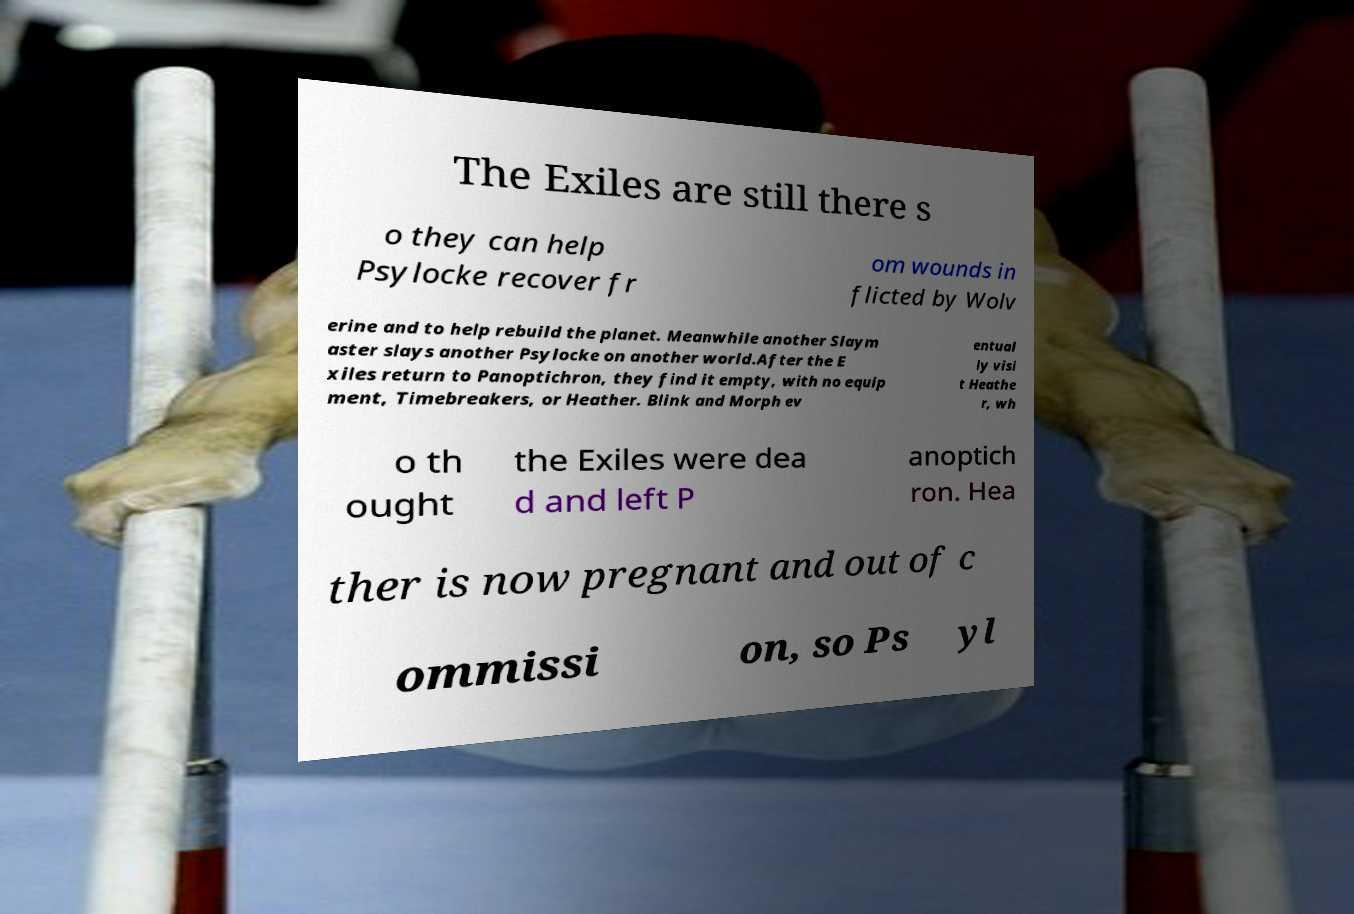Can you accurately transcribe the text from the provided image for me? The Exiles are still there s o they can help Psylocke recover fr om wounds in flicted by Wolv erine and to help rebuild the planet. Meanwhile another Slaym aster slays another Psylocke on another world.After the E xiles return to Panoptichron, they find it empty, with no equip ment, Timebreakers, or Heather. Blink and Morph ev entual ly visi t Heathe r, wh o th ought the Exiles were dea d and left P anoptich ron. Hea ther is now pregnant and out of c ommissi on, so Ps yl 